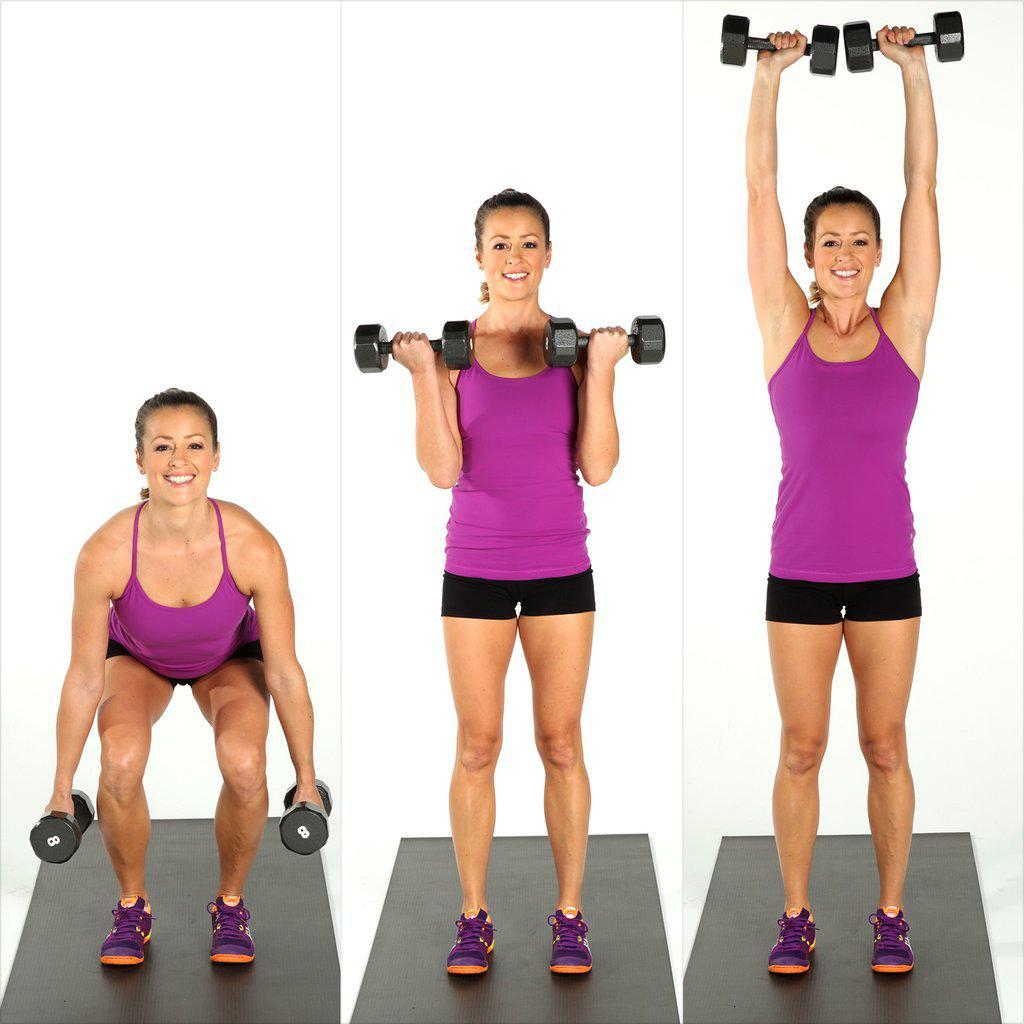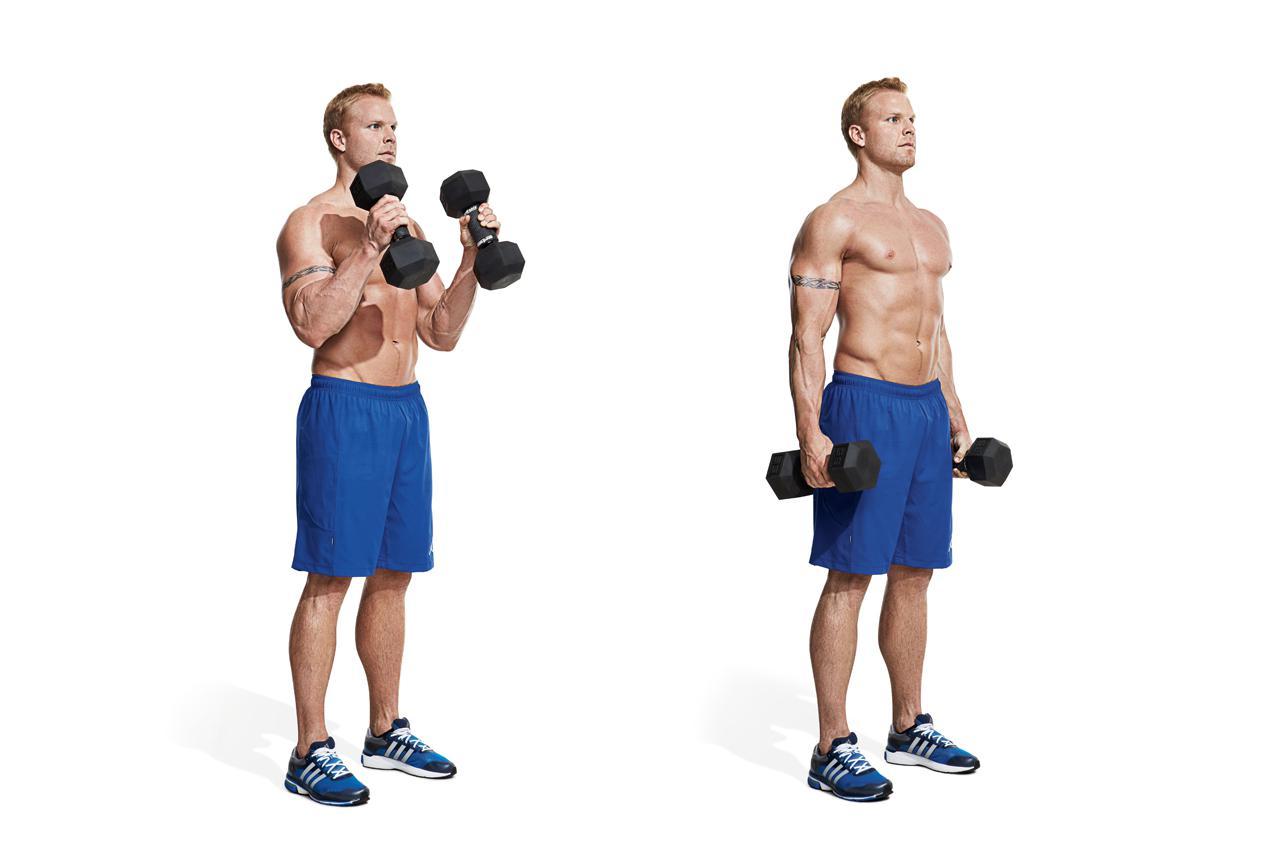The first image is the image on the left, the second image is the image on the right. Evaluate the accuracy of this statement regarding the images: "A man wearing blue short is holding dumbells". Is it true? Answer yes or no. Yes. 